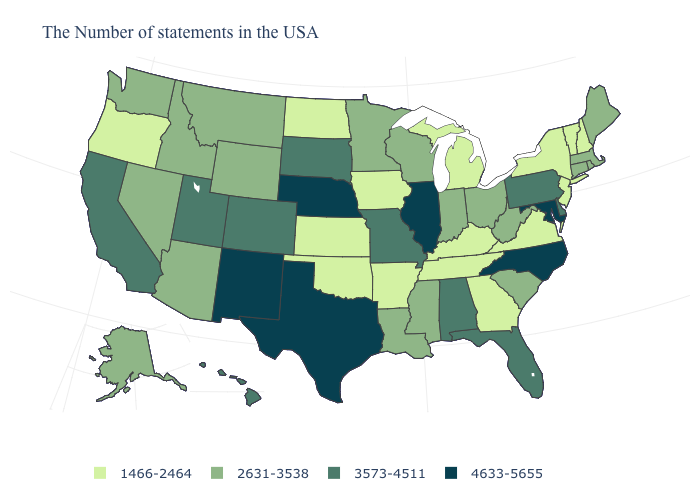Name the states that have a value in the range 4633-5655?
Keep it brief. Maryland, North Carolina, Illinois, Nebraska, Texas, New Mexico. What is the value of South Dakota?
Give a very brief answer. 3573-4511. Name the states that have a value in the range 3573-4511?
Concise answer only. Delaware, Pennsylvania, Florida, Alabama, Missouri, South Dakota, Colorado, Utah, California, Hawaii. Does the map have missing data?
Be succinct. No. How many symbols are there in the legend?
Write a very short answer. 4. What is the lowest value in the USA?
Write a very short answer. 1466-2464. How many symbols are there in the legend?
Concise answer only. 4. Does the map have missing data?
Keep it brief. No. What is the value of New Jersey?
Short answer required. 1466-2464. Is the legend a continuous bar?
Be succinct. No. What is the lowest value in the USA?
Write a very short answer. 1466-2464. Does the map have missing data?
Be succinct. No. Name the states that have a value in the range 3573-4511?
Be succinct. Delaware, Pennsylvania, Florida, Alabama, Missouri, South Dakota, Colorado, Utah, California, Hawaii. Does Maine have a lower value than Washington?
Be succinct. No. What is the value of Oklahoma?
Keep it brief. 1466-2464. 